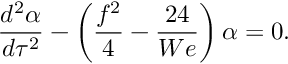Convert formula to latex. <formula><loc_0><loc_0><loc_500><loc_500>\frac { d ^ { 2 } \alpha } { d \tau ^ { 2 } } - \left ( \frac { f ^ { 2 } } { 4 } - \frac { 2 4 } { W e } \right ) \alpha = 0 .</formula> 